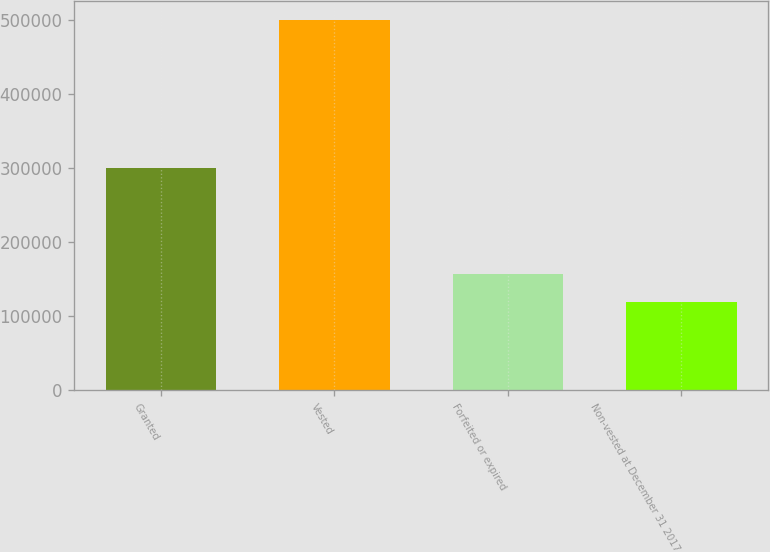<chart> <loc_0><loc_0><loc_500><loc_500><bar_chart><fcel>Granted<fcel>Vested<fcel>Forfeited or expired<fcel>Non-vested at December 31 2017<nl><fcel>300002<fcel>500455<fcel>157106<fcel>118956<nl></chart> 